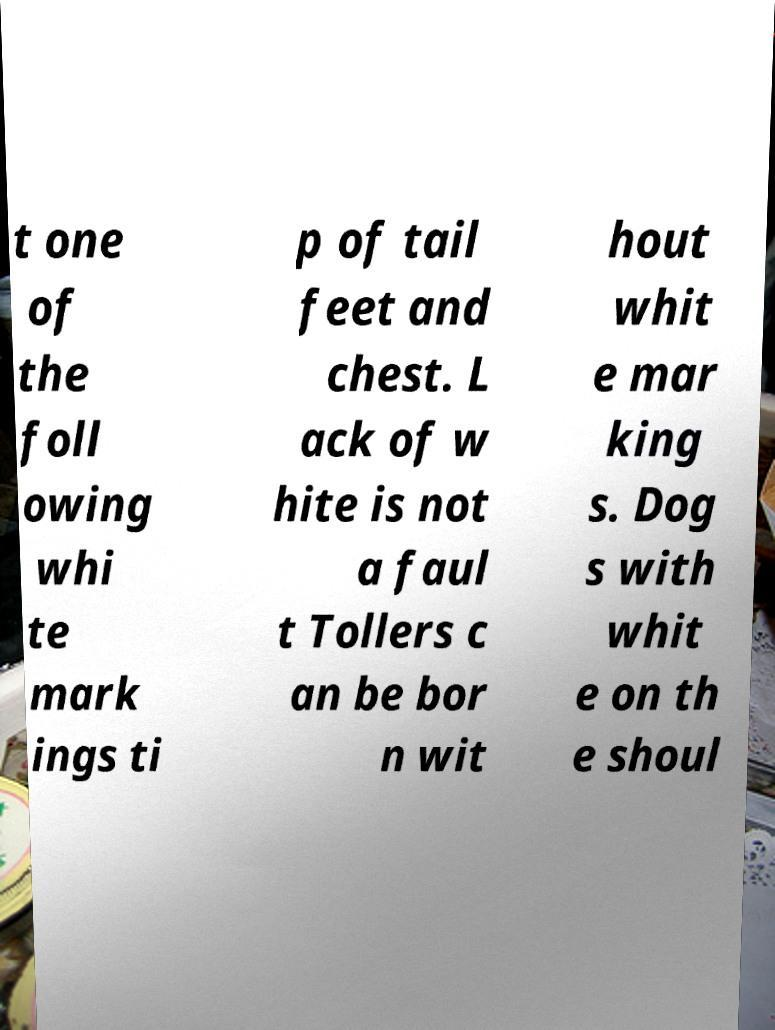Please read and relay the text visible in this image. What does it say? t one of the foll owing whi te mark ings ti p of tail feet and chest. L ack of w hite is not a faul t Tollers c an be bor n wit hout whit e mar king s. Dog s with whit e on th e shoul 